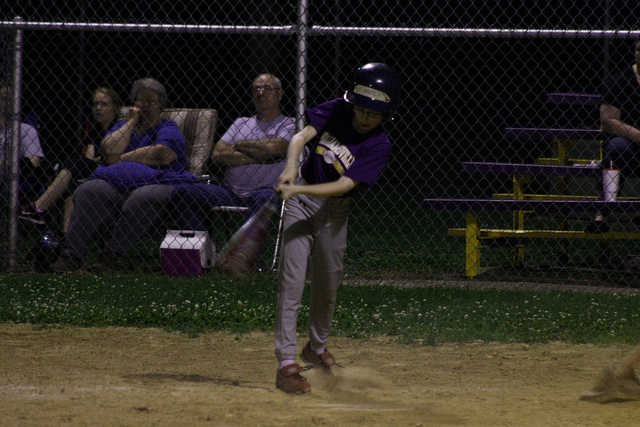Describe the objects in this image and their specific colors. I can see people in black and gray tones, people in black, navy, and gray tones, bench in black, olive, and purple tones, people in black, gray, navy, and purple tones, and people in black and gray tones in this image. 